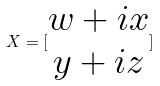Convert formula to latex. <formula><loc_0><loc_0><loc_500><loc_500>X = [ \begin{matrix} w + i x \\ y + i z \end{matrix} ]</formula> 